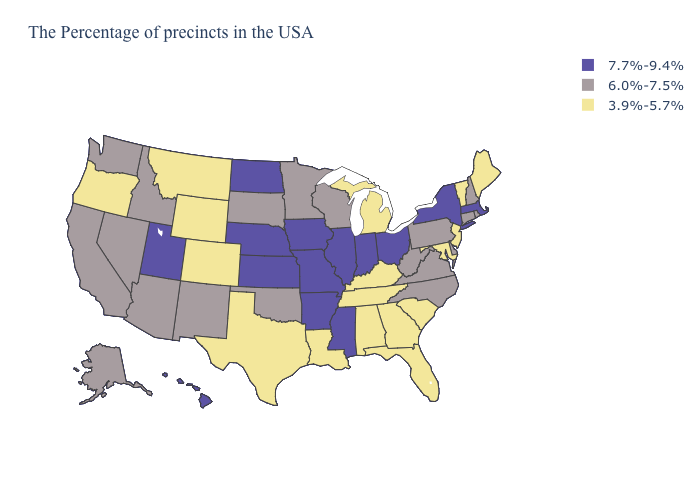What is the lowest value in the Northeast?
Give a very brief answer. 3.9%-5.7%. Which states have the highest value in the USA?
Write a very short answer. Massachusetts, New York, Ohio, Indiana, Illinois, Mississippi, Missouri, Arkansas, Iowa, Kansas, Nebraska, North Dakota, Utah, Hawaii. What is the value of Virginia?
Short answer required. 6.0%-7.5%. Among the states that border Kentucky , does Tennessee have the lowest value?
Concise answer only. Yes. Is the legend a continuous bar?
Quick response, please. No. What is the value of Hawaii?
Keep it brief. 7.7%-9.4%. Which states have the highest value in the USA?
Give a very brief answer. Massachusetts, New York, Ohio, Indiana, Illinois, Mississippi, Missouri, Arkansas, Iowa, Kansas, Nebraska, North Dakota, Utah, Hawaii. Does Oklahoma have the highest value in the South?
Give a very brief answer. No. Name the states that have a value in the range 3.9%-5.7%?
Short answer required. Maine, Vermont, New Jersey, Maryland, South Carolina, Florida, Georgia, Michigan, Kentucky, Alabama, Tennessee, Louisiana, Texas, Wyoming, Colorado, Montana, Oregon. Does North Dakota have the highest value in the USA?
Give a very brief answer. Yes. Which states have the highest value in the USA?
Give a very brief answer. Massachusetts, New York, Ohio, Indiana, Illinois, Mississippi, Missouri, Arkansas, Iowa, Kansas, Nebraska, North Dakota, Utah, Hawaii. What is the lowest value in states that border Delaware?
Give a very brief answer. 3.9%-5.7%. What is the value of Utah?
Short answer required. 7.7%-9.4%. What is the lowest value in states that border Nevada?
Quick response, please. 3.9%-5.7%. Does Michigan have the lowest value in the USA?
Quick response, please. Yes. 